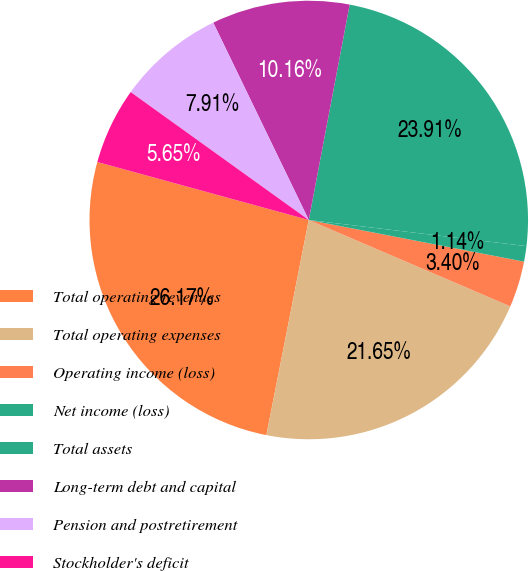Convert chart to OTSL. <chart><loc_0><loc_0><loc_500><loc_500><pie_chart><fcel>Total operating revenues<fcel>Total operating expenses<fcel>Operating income (loss)<fcel>Net income (loss)<fcel>Total assets<fcel>Long-term debt and capital<fcel>Pension and postretirement<fcel>Stockholder's deficit<nl><fcel>26.16%<fcel>21.65%<fcel>3.4%<fcel>1.14%<fcel>23.91%<fcel>10.16%<fcel>7.91%<fcel>5.65%<nl></chart> 